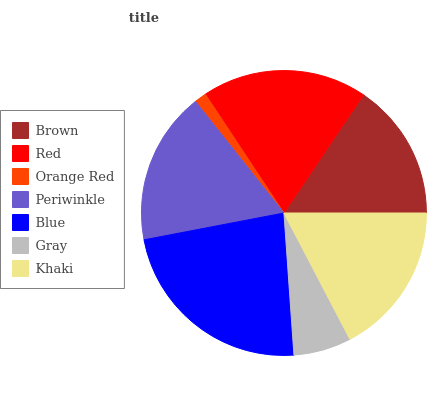Is Orange Red the minimum?
Answer yes or no. Yes. Is Blue the maximum?
Answer yes or no. Yes. Is Red the minimum?
Answer yes or no. No. Is Red the maximum?
Answer yes or no. No. Is Red greater than Brown?
Answer yes or no. Yes. Is Brown less than Red?
Answer yes or no. Yes. Is Brown greater than Red?
Answer yes or no. No. Is Red less than Brown?
Answer yes or no. No. Is Khaki the high median?
Answer yes or no. Yes. Is Khaki the low median?
Answer yes or no. Yes. Is Periwinkle the high median?
Answer yes or no. No. Is Orange Red the low median?
Answer yes or no. No. 